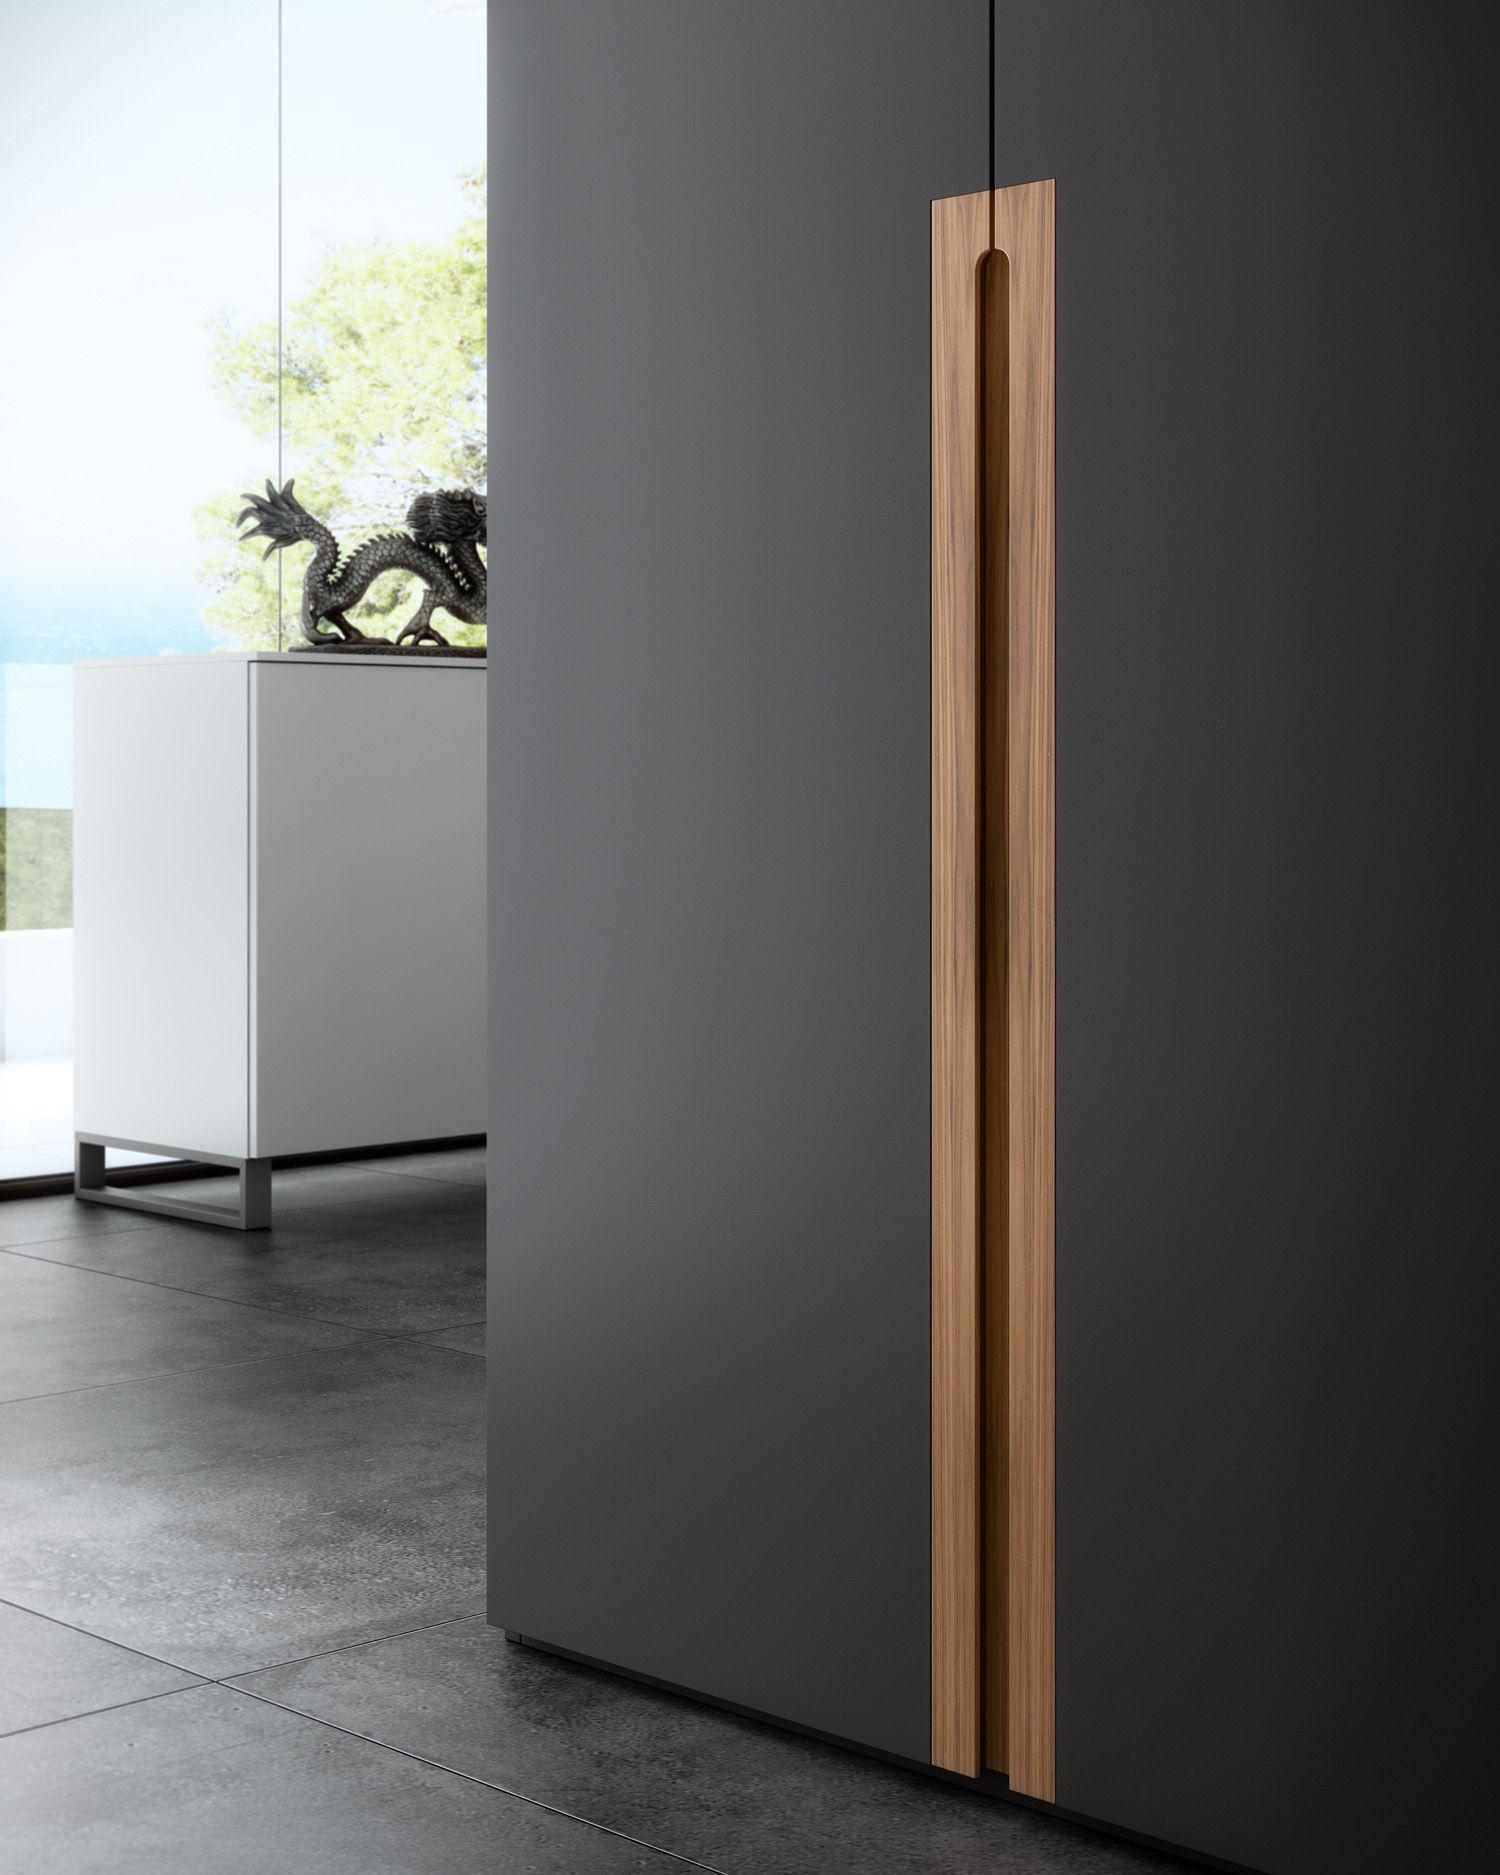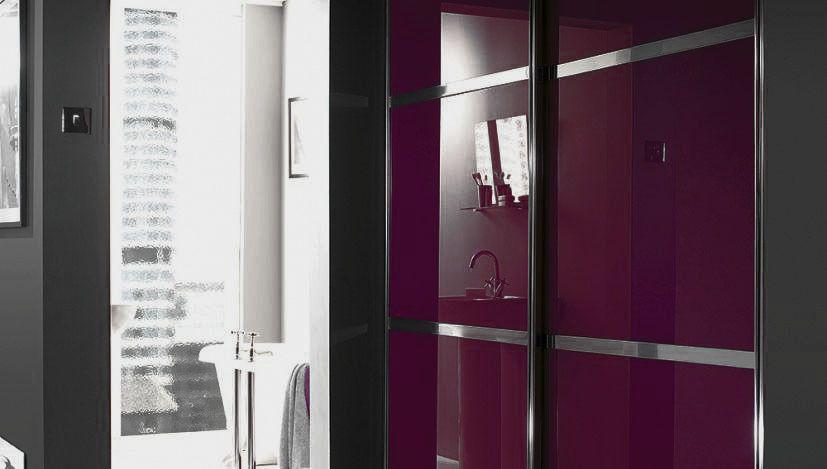The first image is the image on the left, the second image is the image on the right. Evaluate the accuracy of this statement regarding the images: "Both closets are closed.". Is it true? Answer yes or no. Yes. The first image is the image on the left, the second image is the image on the right. For the images displayed, is the sentence "The left image shows a unit with three sliding doors and a band across the front surrounded by a brown top and bottom." factually correct? Answer yes or no. No. 